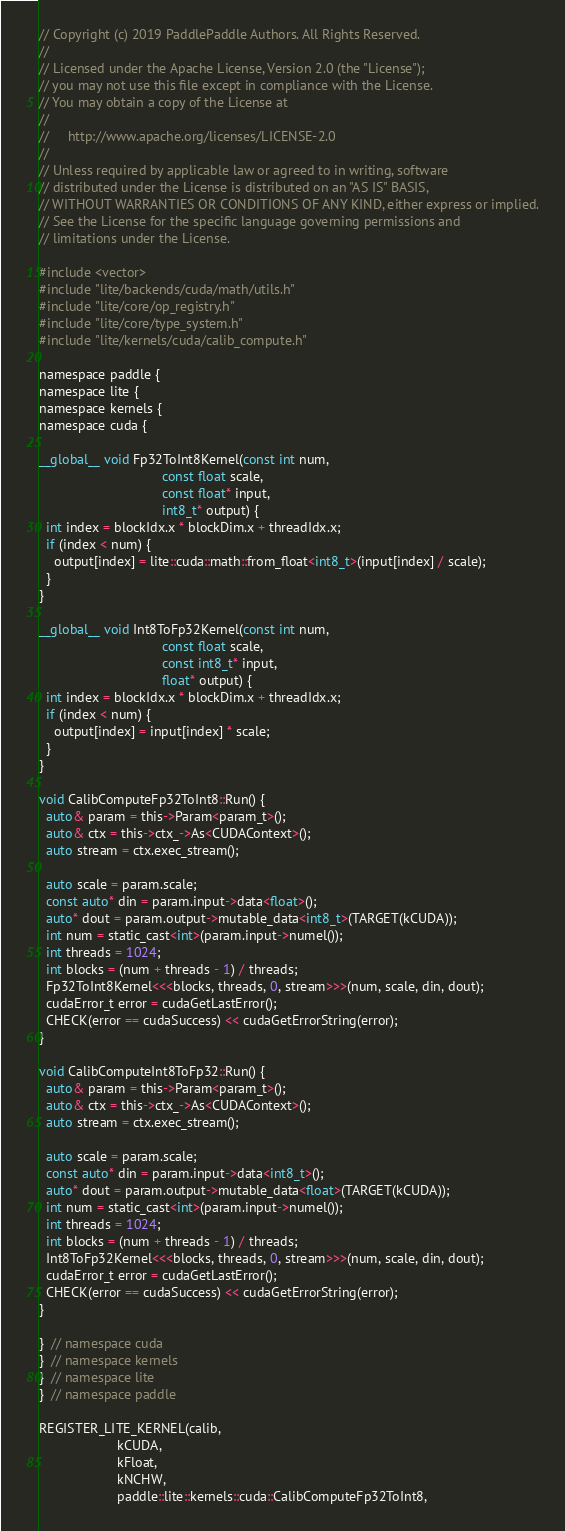Convert code to text. <code><loc_0><loc_0><loc_500><loc_500><_Cuda_>// Copyright (c) 2019 PaddlePaddle Authors. All Rights Reserved.
//
// Licensed under the Apache License, Version 2.0 (the "License");
// you may not use this file except in compliance with the License.
// You may obtain a copy of the License at
//
//     http://www.apache.org/licenses/LICENSE-2.0
//
// Unless required by applicable law or agreed to in writing, software
// distributed under the License is distributed on an "AS IS" BASIS,
// WITHOUT WARRANTIES OR CONDITIONS OF ANY KIND, either express or implied.
// See the License for the specific language governing permissions and
// limitations under the License.

#include <vector>
#include "lite/backends/cuda/math/utils.h"
#include "lite/core/op_registry.h"
#include "lite/core/type_system.h"
#include "lite/kernels/cuda/calib_compute.h"

namespace paddle {
namespace lite {
namespace kernels {
namespace cuda {

__global__ void Fp32ToInt8Kernel(const int num,
                                 const float scale,
                                 const float* input,
                                 int8_t* output) {
  int index = blockIdx.x * blockDim.x + threadIdx.x;
  if (index < num) {
    output[index] = lite::cuda::math::from_float<int8_t>(input[index] / scale);
  }
}

__global__ void Int8ToFp32Kernel(const int num,
                                 const float scale,
                                 const int8_t* input,
                                 float* output) {
  int index = blockIdx.x * blockDim.x + threadIdx.x;
  if (index < num) {
    output[index] = input[index] * scale;
  }
}

void CalibComputeFp32ToInt8::Run() {
  auto& param = this->Param<param_t>();
  auto& ctx = this->ctx_->As<CUDAContext>();
  auto stream = ctx.exec_stream();

  auto scale = param.scale;
  const auto* din = param.input->data<float>();
  auto* dout = param.output->mutable_data<int8_t>(TARGET(kCUDA));
  int num = static_cast<int>(param.input->numel());
  int threads = 1024;
  int blocks = (num + threads - 1) / threads;
  Fp32ToInt8Kernel<<<blocks, threads, 0, stream>>>(num, scale, din, dout);
  cudaError_t error = cudaGetLastError();
  CHECK(error == cudaSuccess) << cudaGetErrorString(error);
}

void CalibComputeInt8ToFp32::Run() {
  auto& param = this->Param<param_t>();
  auto& ctx = this->ctx_->As<CUDAContext>();
  auto stream = ctx.exec_stream();

  auto scale = param.scale;
  const auto* din = param.input->data<int8_t>();
  auto* dout = param.output->mutable_data<float>(TARGET(kCUDA));
  int num = static_cast<int>(param.input->numel());
  int threads = 1024;
  int blocks = (num + threads - 1) / threads;
  Int8ToFp32Kernel<<<blocks, threads, 0, stream>>>(num, scale, din, dout);
  cudaError_t error = cudaGetLastError();
  CHECK(error == cudaSuccess) << cudaGetErrorString(error);
}

}  // namespace cuda
}  // namespace kernels
}  // namespace lite
}  // namespace paddle

REGISTER_LITE_KERNEL(calib,
                     kCUDA,
                     kFloat,
                     kNCHW,
                     paddle::lite::kernels::cuda::CalibComputeFp32ToInt8,</code> 